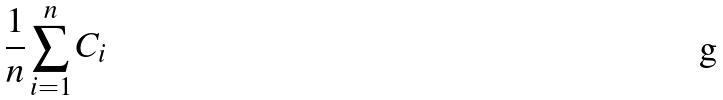<formula> <loc_0><loc_0><loc_500><loc_500>\frac { 1 } { n } \sum _ { i = 1 } ^ { n } C _ { i }</formula> 